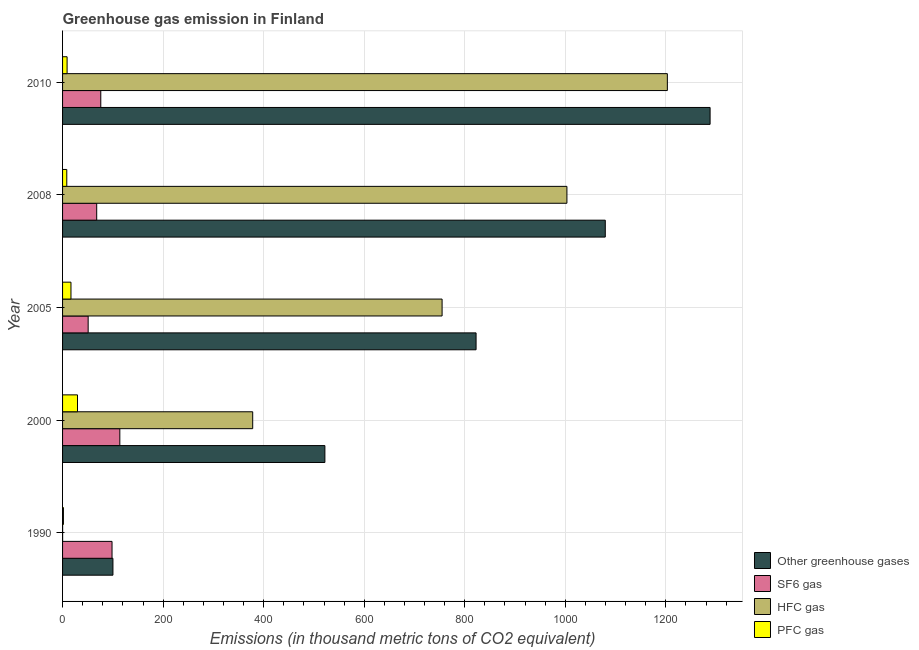How many groups of bars are there?
Keep it short and to the point. 5. Are the number of bars on each tick of the Y-axis equal?
Your answer should be very brief. Yes. In how many cases, is the number of bars for a given year not equal to the number of legend labels?
Ensure brevity in your answer.  0. Across all years, what is the maximum emission of sf6 gas?
Your answer should be very brief. 113.9. Across all years, what is the minimum emission of hfc gas?
Ensure brevity in your answer.  0.1. In which year was the emission of pfc gas minimum?
Your response must be concise. 1990. What is the total emission of sf6 gas in the graph?
Keep it short and to the point. 407.1. What is the difference between the emission of greenhouse gases in 2005 and that in 2010?
Keep it short and to the point. -465.5. What is the difference between the emission of hfc gas in 2008 and the emission of greenhouse gases in 2005?
Provide a succinct answer. 180.7. What is the average emission of greenhouse gases per year?
Ensure brevity in your answer.  762.4. In how many years, is the emission of hfc gas greater than 1280 thousand metric tons?
Make the answer very short. 0. What is the ratio of the emission of greenhouse gases in 2005 to that in 2008?
Your answer should be compact. 0.76. What is the difference between the highest and the second highest emission of pfc gas?
Keep it short and to the point. 13. What is the difference between the highest and the lowest emission of hfc gas?
Offer a terse response. 1202.9. In how many years, is the emission of hfc gas greater than the average emission of hfc gas taken over all years?
Provide a succinct answer. 3. Is it the case that in every year, the sum of the emission of greenhouse gases and emission of sf6 gas is greater than the sum of emission of pfc gas and emission of hfc gas?
Ensure brevity in your answer.  No. What does the 2nd bar from the top in 2000 represents?
Keep it short and to the point. HFC gas. What does the 1st bar from the bottom in 2010 represents?
Ensure brevity in your answer.  Other greenhouse gases. Is it the case that in every year, the sum of the emission of greenhouse gases and emission of sf6 gas is greater than the emission of hfc gas?
Your answer should be very brief. Yes. How many bars are there?
Your answer should be very brief. 20. Where does the legend appear in the graph?
Your answer should be compact. Bottom right. How many legend labels are there?
Offer a terse response. 4. What is the title of the graph?
Provide a short and direct response. Greenhouse gas emission in Finland. Does "PFC gas" appear as one of the legend labels in the graph?
Your answer should be very brief. Yes. What is the label or title of the X-axis?
Your answer should be compact. Emissions (in thousand metric tons of CO2 equivalent). What is the label or title of the Y-axis?
Provide a short and direct response. Year. What is the Emissions (in thousand metric tons of CO2 equivalent) of Other greenhouse gases in 1990?
Offer a terse response. 100.2. What is the Emissions (in thousand metric tons of CO2 equivalent) of SF6 gas in 1990?
Offer a terse response. 98.4. What is the Emissions (in thousand metric tons of CO2 equivalent) of HFC gas in 1990?
Offer a terse response. 0.1. What is the Emissions (in thousand metric tons of CO2 equivalent) of Other greenhouse gases in 2000?
Keep it short and to the point. 521.8. What is the Emissions (in thousand metric tons of CO2 equivalent) of SF6 gas in 2000?
Your answer should be very brief. 113.9. What is the Emissions (in thousand metric tons of CO2 equivalent) in HFC gas in 2000?
Your response must be concise. 378.2. What is the Emissions (in thousand metric tons of CO2 equivalent) of PFC gas in 2000?
Offer a terse response. 29.7. What is the Emissions (in thousand metric tons of CO2 equivalent) of Other greenhouse gases in 2005?
Offer a terse response. 822.5. What is the Emissions (in thousand metric tons of CO2 equivalent) in SF6 gas in 2005?
Offer a terse response. 50.9. What is the Emissions (in thousand metric tons of CO2 equivalent) of HFC gas in 2005?
Provide a succinct answer. 754.9. What is the Emissions (in thousand metric tons of CO2 equivalent) in Other greenhouse gases in 2008?
Provide a succinct answer. 1079.5. What is the Emissions (in thousand metric tons of CO2 equivalent) in SF6 gas in 2008?
Ensure brevity in your answer.  67.9. What is the Emissions (in thousand metric tons of CO2 equivalent) in HFC gas in 2008?
Your answer should be very brief. 1003.2. What is the Emissions (in thousand metric tons of CO2 equivalent) in PFC gas in 2008?
Provide a succinct answer. 8.4. What is the Emissions (in thousand metric tons of CO2 equivalent) in Other greenhouse gases in 2010?
Give a very brief answer. 1288. What is the Emissions (in thousand metric tons of CO2 equivalent) of HFC gas in 2010?
Offer a terse response. 1203. What is the Emissions (in thousand metric tons of CO2 equivalent) in PFC gas in 2010?
Give a very brief answer. 9. Across all years, what is the maximum Emissions (in thousand metric tons of CO2 equivalent) of Other greenhouse gases?
Ensure brevity in your answer.  1288. Across all years, what is the maximum Emissions (in thousand metric tons of CO2 equivalent) of SF6 gas?
Your response must be concise. 113.9. Across all years, what is the maximum Emissions (in thousand metric tons of CO2 equivalent) in HFC gas?
Your response must be concise. 1203. Across all years, what is the maximum Emissions (in thousand metric tons of CO2 equivalent) in PFC gas?
Make the answer very short. 29.7. Across all years, what is the minimum Emissions (in thousand metric tons of CO2 equivalent) of Other greenhouse gases?
Keep it short and to the point. 100.2. Across all years, what is the minimum Emissions (in thousand metric tons of CO2 equivalent) in SF6 gas?
Your response must be concise. 50.9. Across all years, what is the minimum Emissions (in thousand metric tons of CO2 equivalent) in PFC gas?
Your response must be concise. 1.7. What is the total Emissions (in thousand metric tons of CO2 equivalent) in Other greenhouse gases in the graph?
Offer a very short reply. 3812. What is the total Emissions (in thousand metric tons of CO2 equivalent) of SF6 gas in the graph?
Ensure brevity in your answer.  407.1. What is the total Emissions (in thousand metric tons of CO2 equivalent) of HFC gas in the graph?
Offer a very short reply. 3339.4. What is the total Emissions (in thousand metric tons of CO2 equivalent) in PFC gas in the graph?
Provide a short and direct response. 65.5. What is the difference between the Emissions (in thousand metric tons of CO2 equivalent) in Other greenhouse gases in 1990 and that in 2000?
Ensure brevity in your answer.  -421.6. What is the difference between the Emissions (in thousand metric tons of CO2 equivalent) of SF6 gas in 1990 and that in 2000?
Offer a very short reply. -15.5. What is the difference between the Emissions (in thousand metric tons of CO2 equivalent) in HFC gas in 1990 and that in 2000?
Offer a terse response. -378.1. What is the difference between the Emissions (in thousand metric tons of CO2 equivalent) of Other greenhouse gases in 1990 and that in 2005?
Provide a short and direct response. -722.3. What is the difference between the Emissions (in thousand metric tons of CO2 equivalent) of SF6 gas in 1990 and that in 2005?
Your answer should be compact. 47.5. What is the difference between the Emissions (in thousand metric tons of CO2 equivalent) of HFC gas in 1990 and that in 2005?
Your answer should be compact. -754.8. What is the difference between the Emissions (in thousand metric tons of CO2 equivalent) of PFC gas in 1990 and that in 2005?
Offer a terse response. -15. What is the difference between the Emissions (in thousand metric tons of CO2 equivalent) in Other greenhouse gases in 1990 and that in 2008?
Your response must be concise. -979.3. What is the difference between the Emissions (in thousand metric tons of CO2 equivalent) of SF6 gas in 1990 and that in 2008?
Make the answer very short. 30.5. What is the difference between the Emissions (in thousand metric tons of CO2 equivalent) of HFC gas in 1990 and that in 2008?
Provide a succinct answer. -1003.1. What is the difference between the Emissions (in thousand metric tons of CO2 equivalent) in PFC gas in 1990 and that in 2008?
Your response must be concise. -6.7. What is the difference between the Emissions (in thousand metric tons of CO2 equivalent) in Other greenhouse gases in 1990 and that in 2010?
Provide a succinct answer. -1187.8. What is the difference between the Emissions (in thousand metric tons of CO2 equivalent) of SF6 gas in 1990 and that in 2010?
Provide a succinct answer. 22.4. What is the difference between the Emissions (in thousand metric tons of CO2 equivalent) in HFC gas in 1990 and that in 2010?
Your response must be concise. -1202.9. What is the difference between the Emissions (in thousand metric tons of CO2 equivalent) in PFC gas in 1990 and that in 2010?
Keep it short and to the point. -7.3. What is the difference between the Emissions (in thousand metric tons of CO2 equivalent) in Other greenhouse gases in 2000 and that in 2005?
Your answer should be very brief. -300.7. What is the difference between the Emissions (in thousand metric tons of CO2 equivalent) of SF6 gas in 2000 and that in 2005?
Your response must be concise. 63. What is the difference between the Emissions (in thousand metric tons of CO2 equivalent) in HFC gas in 2000 and that in 2005?
Give a very brief answer. -376.7. What is the difference between the Emissions (in thousand metric tons of CO2 equivalent) of PFC gas in 2000 and that in 2005?
Your answer should be very brief. 13. What is the difference between the Emissions (in thousand metric tons of CO2 equivalent) in Other greenhouse gases in 2000 and that in 2008?
Give a very brief answer. -557.7. What is the difference between the Emissions (in thousand metric tons of CO2 equivalent) of HFC gas in 2000 and that in 2008?
Give a very brief answer. -625. What is the difference between the Emissions (in thousand metric tons of CO2 equivalent) in PFC gas in 2000 and that in 2008?
Your response must be concise. 21.3. What is the difference between the Emissions (in thousand metric tons of CO2 equivalent) of Other greenhouse gases in 2000 and that in 2010?
Give a very brief answer. -766.2. What is the difference between the Emissions (in thousand metric tons of CO2 equivalent) of SF6 gas in 2000 and that in 2010?
Keep it short and to the point. 37.9. What is the difference between the Emissions (in thousand metric tons of CO2 equivalent) of HFC gas in 2000 and that in 2010?
Your answer should be compact. -824.8. What is the difference between the Emissions (in thousand metric tons of CO2 equivalent) of PFC gas in 2000 and that in 2010?
Your answer should be very brief. 20.7. What is the difference between the Emissions (in thousand metric tons of CO2 equivalent) in Other greenhouse gases in 2005 and that in 2008?
Provide a short and direct response. -257. What is the difference between the Emissions (in thousand metric tons of CO2 equivalent) of HFC gas in 2005 and that in 2008?
Offer a terse response. -248.3. What is the difference between the Emissions (in thousand metric tons of CO2 equivalent) of PFC gas in 2005 and that in 2008?
Your response must be concise. 8.3. What is the difference between the Emissions (in thousand metric tons of CO2 equivalent) of Other greenhouse gases in 2005 and that in 2010?
Your answer should be very brief. -465.5. What is the difference between the Emissions (in thousand metric tons of CO2 equivalent) in SF6 gas in 2005 and that in 2010?
Your response must be concise. -25.1. What is the difference between the Emissions (in thousand metric tons of CO2 equivalent) in HFC gas in 2005 and that in 2010?
Give a very brief answer. -448.1. What is the difference between the Emissions (in thousand metric tons of CO2 equivalent) of Other greenhouse gases in 2008 and that in 2010?
Ensure brevity in your answer.  -208.5. What is the difference between the Emissions (in thousand metric tons of CO2 equivalent) in SF6 gas in 2008 and that in 2010?
Offer a terse response. -8.1. What is the difference between the Emissions (in thousand metric tons of CO2 equivalent) of HFC gas in 2008 and that in 2010?
Ensure brevity in your answer.  -199.8. What is the difference between the Emissions (in thousand metric tons of CO2 equivalent) of PFC gas in 2008 and that in 2010?
Make the answer very short. -0.6. What is the difference between the Emissions (in thousand metric tons of CO2 equivalent) in Other greenhouse gases in 1990 and the Emissions (in thousand metric tons of CO2 equivalent) in SF6 gas in 2000?
Give a very brief answer. -13.7. What is the difference between the Emissions (in thousand metric tons of CO2 equivalent) in Other greenhouse gases in 1990 and the Emissions (in thousand metric tons of CO2 equivalent) in HFC gas in 2000?
Provide a succinct answer. -278. What is the difference between the Emissions (in thousand metric tons of CO2 equivalent) of Other greenhouse gases in 1990 and the Emissions (in thousand metric tons of CO2 equivalent) of PFC gas in 2000?
Your response must be concise. 70.5. What is the difference between the Emissions (in thousand metric tons of CO2 equivalent) of SF6 gas in 1990 and the Emissions (in thousand metric tons of CO2 equivalent) of HFC gas in 2000?
Offer a terse response. -279.8. What is the difference between the Emissions (in thousand metric tons of CO2 equivalent) in SF6 gas in 1990 and the Emissions (in thousand metric tons of CO2 equivalent) in PFC gas in 2000?
Keep it short and to the point. 68.7. What is the difference between the Emissions (in thousand metric tons of CO2 equivalent) in HFC gas in 1990 and the Emissions (in thousand metric tons of CO2 equivalent) in PFC gas in 2000?
Provide a succinct answer. -29.6. What is the difference between the Emissions (in thousand metric tons of CO2 equivalent) in Other greenhouse gases in 1990 and the Emissions (in thousand metric tons of CO2 equivalent) in SF6 gas in 2005?
Provide a short and direct response. 49.3. What is the difference between the Emissions (in thousand metric tons of CO2 equivalent) of Other greenhouse gases in 1990 and the Emissions (in thousand metric tons of CO2 equivalent) of HFC gas in 2005?
Your response must be concise. -654.7. What is the difference between the Emissions (in thousand metric tons of CO2 equivalent) of Other greenhouse gases in 1990 and the Emissions (in thousand metric tons of CO2 equivalent) of PFC gas in 2005?
Provide a succinct answer. 83.5. What is the difference between the Emissions (in thousand metric tons of CO2 equivalent) in SF6 gas in 1990 and the Emissions (in thousand metric tons of CO2 equivalent) in HFC gas in 2005?
Ensure brevity in your answer.  -656.5. What is the difference between the Emissions (in thousand metric tons of CO2 equivalent) in SF6 gas in 1990 and the Emissions (in thousand metric tons of CO2 equivalent) in PFC gas in 2005?
Provide a short and direct response. 81.7. What is the difference between the Emissions (in thousand metric tons of CO2 equivalent) of HFC gas in 1990 and the Emissions (in thousand metric tons of CO2 equivalent) of PFC gas in 2005?
Give a very brief answer. -16.6. What is the difference between the Emissions (in thousand metric tons of CO2 equivalent) of Other greenhouse gases in 1990 and the Emissions (in thousand metric tons of CO2 equivalent) of SF6 gas in 2008?
Offer a very short reply. 32.3. What is the difference between the Emissions (in thousand metric tons of CO2 equivalent) of Other greenhouse gases in 1990 and the Emissions (in thousand metric tons of CO2 equivalent) of HFC gas in 2008?
Make the answer very short. -903. What is the difference between the Emissions (in thousand metric tons of CO2 equivalent) of Other greenhouse gases in 1990 and the Emissions (in thousand metric tons of CO2 equivalent) of PFC gas in 2008?
Your answer should be compact. 91.8. What is the difference between the Emissions (in thousand metric tons of CO2 equivalent) of SF6 gas in 1990 and the Emissions (in thousand metric tons of CO2 equivalent) of HFC gas in 2008?
Your answer should be compact. -904.8. What is the difference between the Emissions (in thousand metric tons of CO2 equivalent) in SF6 gas in 1990 and the Emissions (in thousand metric tons of CO2 equivalent) in PFC gas in 2008?
Keep it short and to the point. 90. What is the difference between the Emissions (in thousand metric tons of CO2 equivalent) in Other greenhouse gases in 1990 and the Emissions (in thousand metric tons of CO2 equivalent) in SF6 gas in 2010?
Your answer should be very brief. 24.2. What is the difference between the Emissions (in thousand metric tons of CO2 equivalent) in Other greenhouse gases in 1990 and the Emissions (in thousand metric tons of CO2 equivalent) in HFC gas in 2010?
Give a very brief answer. -1102.8. What is the difference between the Emissions (in thousand metric tons of CO2 equivalent) in Other greenhouse gases in 1990 and the Emissions (in thousand metric tons of CO2 equivalent) in PFC gas in 2010?
Offer a very short reply. 91.2. What is the difference between the Emissions (in thousand metric tons of CO2 equivalent) in SF6 gas in 1990 and the Emissions (in thousand metric tons of CO2 equivalent) in HFC gas in 2010?
Provide a short and direct response. -1104.6. What is the difference between the Emissions (in thousand metric tons of CO2 equivalent) of SF6 gas in 1990 and the Emissions (in thousand metric tons of CO2 equivalent) of PFC gas in 2010?
Your response must be concise. 89.4. What is the difference between the Emissions (in thousand metric tons of CO2 equivalent) in HFC gas in 1990 and the Emissions (in thousand metric tons of CO2 equivalent) in PFC gas in 2010?
Your response must be concise. -8.9. What is the difference between the Emissions (in thousand metric tons of CO2 equivalent) of Other greenhouse gases in 2000 and the Emissions (in thousand metric tons of CO2 equivalent) of SF6 gas in 2005?
Make the answer very short. 470.9. What is the difference between the Emissions (in thousand metric tons of CO2 equivalent) in Other greenhouse gases in 2000 and the Emissions (in thousand metric tons of CO2 equivalent) in HFC gas in 2005?
Provide a succinct answer. -233.1. What is the difference between the Emissions (in thousand metric tons of CO2 equivalent) in Other greenhouse gases in 2000 and the Emissions (in thousand metric tons of CO2 equivalent) in PFC gas in 2005?
Keep it short and to the point. 505.1. What is the difference between the Emissions (in thousand metric tons of CO2 equivalent) in SF6 gas in 2000 and the Emissions (in thousand metric tons of CO2 equivalent) in HFC gas in 2005?
Offer a very short reply. -641. What is the difference between the Emissions (in thousand metric tons of CO2 equivalent) of SF6 gas in 2000 and the Emissions (in thousand metric tons of CO2 equivalent) of PFC gas in 2005?
Your response must be concise. 97.2. What is the difference between the Emissions (in thousand metric tons of CO2 equivalent) in HFC gas in 2000 and the Emissions (in thousand metric tons of CO2 equivalent) in PFC gas in 2005?
Your answer should be compact. 361.5. What is the difference between the Emissions (in thousand metric tons of CO2 equivalent) in Other greenhouse gases in 2000 and the Emissions (in thousand metric tons of CO2 equivalent) in SF6 gas in 2008?
Offer a terse response. 453.9. What is the difference between the Emissions (in thousand metric tons of CO2 equivalent) in Other greenhouse gases in 2000 and the Emissions (in thousand metric tons of CO2 equivalent) in HFC gas in 2008?
Your response must be concise. -481.4. What is the difference between the Emissions (in thousand metric tons of CO2 equivalent) of Other greenhouse gases in 2000 and the Emissions (in thousand metric tons of CO2 equivalent) of PFC gas in 2008?
Your response must be concise. 513.4. What is the difference between the Emissions (in thousand metric tons of CO2 equivalent) in SF6 gas in 2000 and the Emissions (in thousand metric tons of CO2 equivalent) in HFC gas in 2008?
Make the answer very short. -889.3. What is the difference between the Emissions (in thousand metric tons of CO2 equivalent) of SF6 gas in 2000 and the Emissions (in thousand metric tons of CO2 equivalent) of PFC gas in 2008?
Give a very brief answer. 105.5. What is the difference between the Emissions (in thousand metric tons of CO2 equivalent) of HFC gas in 2000 and the Emissions (in thousand metric tons of CO2 equivalent) of PFC gas in 2008?
Offer a very short reply. 369.8. What is the difference between the Emissions (in thousand metric tons of CO2 equivalent) in Other greenhouse gases in 2000 and the Emissions (in thousand metric tons of CO2 equivalent) in SF6 gas in 2010?
Provide a short and direct response. 445.8. What is the difference between the Emissions (in thousand metric tons of CO2 equivalent) in Other greenhouse gases in 2000 and the Emissions (in thousand metric tons of CO2 equivalent) in HFC gas in 2010?
Your response must be concise. -681.2. What is the difference between the Emissions (in thousand metric tons of CO2 equivalent) of Other greenhouse gases in 2000 and the Emissions (in thousand metric tons of CO2 equivalent) of PFC gas in 2010?
Ensure brevity in your answer.  512.8. What is the difference between the Emissions (in thousand metric tons of CO2 equivalent) in SF6 gas in 2000 and the Emissions (in thousand metric tons of CO2 equivalent) in HFC gas in 2010?
Give a very brief answer. -1089.1. What is the difference between the Emissions (in thousand metric tons of CO2 equivalent) of SF6 gas in 2000 and the Emissions (in thousand metric tons of CO2 equivalent) of PFC gas in 2010?
Offer a very short reply. 104.9. What is the difference between the Emissions (in thousand metric tons of CO2 equivalent) of HFC gas in 2000 and the Emissions (in thousand metric tons of CO2 equivalent) of PFC gas in 2010?
Your answer should be compact. 369.2. What is the difference between the Emissions (in thousand metric tons of CO2 equivalent) in Other greenhouse gases in 2005 and the Emissions (in thousand metric tons of CO2 equivalent) in SF6 gas in 2008?
Your response must be concise. 754.6. What is the difference between the Emissions (in thousand metric tons of CO2 equivalent) of Other greenhouse gases in 2005 and the Emissions (in thousand metric tons of CO2 equivalent) of HFC gas in 2008?
Your answer should be very brief. -180.7. What is the difference between the Emissions (in thousand metric tons of CO2 equivalent) in Other greenhouse gases in 2005 and the Emissions (in thousand metric tons of CO2 equivalent) in PFC gas in 2008?
Your answer should be compact. 814.1. What is the difference between the Emissions (in thousand metric tons of CO2 equivalent) of SF6 gas in 2005 and the Emissions (in thousand metric tons of CO2 equivalent) of HFC gas in 2008?
Your answer should be very brief. -952.3. What is the difference between the Emissions (in thousand metric tons of CO2 equivalent) in SF6 gas in 2005 and the Emissions (in thousand metric tons of CO2 equivalent) in PFC gas in 2008?
Offer a very short reply. 42.5. What is the difference between the Emissions (in thousand metric tons of CO2 equivalent) in HFC gas in 2005 and the Emissions (in thousand metric tons of CO2 equivalent) in PFC gas in 2008?
Your answer should be very brief. 746.5. What is the difference between the Emissions (in thousand metric tons of CO2 equivalent) in Other greenhouse gases in 2005 and the Emissions (in thousand metric tons of CO2 equivalent) in SF6 gas in 2010?
Keep it short and to the point. 746.5. What is the difference between the Emissions (in thousand metric tons of CO2 equivalent) of Other greenhouse gases in 2005 and the Emissions (in thousand metric tons of CO2 equivalent) of HFC gas in 2010?
Ensure brevity in your answer.  -380.5. What is the difference between the Emissions (in thousand metric tons of CO2 equivalent) in Other greenhouse gases in 2005 and the Emissions (in thousand metric tons of CO2 equivalent) in PFC gas in 2010?
Your answer should be very brief. 813.5. What is the difference between the Emissions (in thousand metric tons of CO2 equivalent) of SF6 gas in 2005 and the Emissions (in thousand metric tons of CO2 equivalent) of HFC gas in 2010?
Keep it short and to the point. -1152.1. What is the difference between the Emissions (in thousand metric tons of CO2 equivalent) of SF6 gas in 2005 and the Emissions (in thousand metric tons of CO2 equivalent) of PFC gas in 2010?
Give a very brief answer. 41.9. What is the difference between the Emissions (in thousand metric tons of CO2 equivalent) of HFC gas in 2005 and the Emissions (in thousand metric tons of CO2 equivalent) of PFC gas in 2010?
Provide a succinct answer. 745.9. What is the difference between the Emissions (in thousand metric tons of CO2 equivalent) in Other greenhouse gases in 2008 and the Emissions (in thousand metric tons of CO2 equivalent) in SF6 gas in 2010?
Your answer should be very brief. 1003.5. What is the difference between the Emissions (in thousand metric tons of CO2 equivalent) in Other greenhouse gases in 2008 and the Emissions (in thousand metric tons of CO2 equivalent) in HFC gas in 2010?
Offer a very short reply. -123.5. What is the difference between the Emissions (in thousand metric tons of CO2 equivalent) in Other greenhouse gases in 2008 and the Emissions (in thousand metric tons of CO2 equivalent) in PFC gas in 2010?
Your response must be concise. 1070.5. What is the difference between the Emissions (in thousand metric tons of CO2 equivalent) in SF6 gas in 2008 and the Emissions (in thousand metric tons of CO2 equivalent) in HFC gas in 2010?
Give a very brief answer. -1135.1. What is the difference between the Emissions (in thousand metric tons of CO2 equivalent) of SF6 gas in 2008 and the Emissions (in thousand metric tons of CO2 equivalent) of PFC gas in 2010?
Offer a very short reply. 58.9. What is the difference between the Emissions (in thousand metric tons of CO2 equivalent) in HFC gas in 2008 and the Emissions (in thousand metric tons of CO2 equivalent) in PFC gas in 2010?
Your response must be concise. 994.2. What is the average Emissions (in thousand metric tons of CO2 equivalent) of Other greenhouse gases per year?
Your answer should be compact. 762.4. What is the average Emissions (in thousand metric tons of CO2 equivalent) in SF6 gas per year?
Your answer should be very brief. 81.42. What is the average Emissions (in thousand metric tons of CO2 equivalent) of HFC gas per year?
Provide a succinct answer. 667.88. In the year 1990, what is the difference between the Emissions (in thousand metric tons of CO2 equivalent) of Other greenhouse gases and Emissions (in thousand metric tons of CO2 equivalent) of SF6 gas?
Give a very brief answer. 1.8. In the year 1990, what is the difference between the Emissions (in thousand metric tons of CO2 equivalent) in Other greenhouse gases and Emissions (in thousand metric tons of CO2 equivalent) in HFC gas?
Your answer should be very brief. 100.1. In the year 1990, what is the difference between the Emissions (in thousand metric tons of CO2 equivalent) of Other greenhouse gases and Emissions (in thousand metric tons of CO2 equivalent) of PFC gas?
Provide a short and direct response. 98.5. In the year 1990, what is the difference between the Emissions (in thousand metric tons of CO2 equivalent) of SF6 gas and Emissions (in thousand metric tons of CO2 equivalent) of HFC gas?
Provide a succinct answer. 98.3. In the year 1990, what is the difference between the Emissions (in thousand metric tons of CO2 equivalent) of SF6 gas and Emissions (in thousand metric tons of CO2 equivalent) of PFC gas?
Give a very brief answer. 96.7. In the year 2000, what is the difference between the Emissions (in thousand metric tons of CO2 equivalent) of Other greenhouse gases and Emissions (in thousand metric tons of CO2 equivalent) of SF6 gas?
Keep it short and to the point. 407.9. In the year 2000, what is the difference between the Emissions (in thousand metric tons of CO2 equivalent) in Other greenhouse gases and Emissions (in thousand metric tons of CO2 equivalent) in HFC gas?
Make the answer very short. 143.6. In the year 2000, what is the difference between the Emissions (in thousand metric tons of CO2 equivalent) in Other greenhouse gases and Emissions (in thousand metric tons of CO2 equivalent) in PFC gas?
Your response must be concise. 492.1. In the year 2000, what is the difference between the Emissions (in thousand metric tons of CO2 equivalent) of SF6 gas and Emissions (in thousand metric tons of CO2 equivalent) of HFC gas?
Your answer should be compact. -264.3. In the year 2000, what is the difference between the Emissions (in thousand metric tons of CO2 equivalent) of SF6 gas and Emissions (in thousand metric tons of CO2 equivalent) of PFC gas?
Provide a succinct answer. 84.2. In the year 2000, what is the difference between the Emissions (in thousand metric tons of CO2 equivalent) in HFC gas and Emissions (in thousand metric tons of CO2 equivalent) in PFC gas?
Keep it short and to the point. 348.5. In the year 2005, what is the difference between the Emissions (in thousand metric tons of CO2 equivalent) of Other greenhouse gases and Emissions (in thousand metric tons of CO2 equivalent) of SF6 gas?
Ensure brevity in your answer.  771.6. In the year 2005, what is the difference between the Emissions (in thousand metric tons of CO2 equivalent) of Other greenhouse gases and Emissions (in thousand metric tons of CO2 equivalent) of HFC gas?
Your response must be concise. 67.6. In the year 2005, what is the difference between the Emissions (in thousand metric tons of CO2 equivalent) of Other greenhouse gases and Emissions (in thousand metric tons of CO2 equivalent) of PFC gas?
Give a very brief answer. 805.8. In the year 2005, what is the difference between the Emissions (in thousand metric tons of CO2 equivalent) in SF6 gas and Emissions (in thousand metric tons of CO2 equivalent) in HFC gas?
Your response must be concise. -704. In the year 2005, what is the difference between the Emissions (in thousand metric tons of CO2 equivalent) in SF6 gas and Emissions (in thousand metric tons of CO2 equivalent) in PFC gas?
Offer a very short reply. 34.2. In the year 2005, what is the difference between the Emissions (in thousand metric tons of CO2 equivalent) in HFC gas and Emissions (in thousand metric tons of CO2 equivalent) in PFC gas?
Make the answer very short. 738.2. In the year 2008, what is the difference between the Emissions (in thousand metric tons of CO2 equivalent) of Other greenhouse gases and Emissions (in thousand metric tons of CO2 equivalent) of SF6 gas?
Provide a short and direct response. 1011.6. In the year 2008, what is the difference between the Emissions (in thousand metric tons of CO2 equivalent) in Other greenhouse gases and Emissions (in thousand metric tons of CO2 equivalent) in HFC gas?
Provide a succinct answer. 76.3. In the year 2008, what is the difference between the Emissions (in thousand metric tons of CO2 equivalent) in Other greenhouse gases and Emissions (in thousand metric tons of CO2 equivalent) in PFC gas?
Your response must be concise. 1071.1. In the year 2008, what is the difference between the Emissions (in thousand metric tons of CO2 equivalent) of SF6 gas and Emissions (in thousand metric tons of CO2 equivalent) of HFC gas?
Make the answer very short. -935.3. In the year 2008, what is the difference between the Emissions (in thousand metric tons of CO2 equivalent) of SF6 gas and Emissions (in thousand metric tons of CO2 equivalent) of PFC gas?
Your response must be concise. 59.5. In the year 2008, what is the difference between the Emissions (in thousand metric tons of CO2 equivalent) in HFC gas and Emissions (in thousand metric tons of CO2 equivalent) in PFC gas?
Make the answer very short. 994.8. In the year 2010, what is the difference between the Emissions (in thousand metric tons of CO2 equivalent) of Other greenhouse gases and Emissions (in thousand metric tons of CO2 equivalent) of SF6 gas?
Your answer should be very brief. 1212. In the year 2010, what is the difference between the Emissions (in thousand metric tons of CO2 equivalent) in Other greenhouse gases and Emissions (in thousand metric tons of CO2 equivalent) in PFC gas?
Provide a succinct answer. 1279. In the year 2010, what is the difference between the Emissions (in thousand metric tons of CO2 equivalent) in SF6 gas and Emissions (in thousand metric tons of CO2 equivalent) in HFC gas?
Your answer should be very brief. -1127. In the year 2010, what is the difference between the Emissions (in thousand metric tons of CO2 equivalent) of HFC gas and Emissions (in thousand metric tons of CO2 equivalent) of PFC gas?
Provide a succinct answer. 1194. What is the ratio of the Emissions (in thousand metric tons of CO2 equivalent) of Other greenhouse gases in 1990 to that in 2000?
Ensure brevity in your answer.  0.19. What is the ratio of the Emissions (in thousand metric tons of CO2 equivalent) of SF6 gas in 1990 to that in 2000?
Ensure brevity in your answer.  0.86. What is the ratio of the Emissions (in thousand metric tons of CO2 equivalent) in PFC gas in 1990 to that in 2000?
Provide a short and direct response. 0.06. What is the ratio of the Emissions (in thousand metric tons of CO2 equivalent) in Other greenhouse gases in 1990 to that in 2005?
Ensure brevity in your answer.  0.12. What is the ratio of the Emissions (in thousand metric tons of CO2 equivalent) of SF6 gas in 1990 to that in 2005?
Keep it short and to the point. 1.93. What is the ratio of the Emissions (in thousand metric tons of CO2 equivalent) in PFC gas in 1990 to that in 2005?
Give a very brief answer. 0.1. What is the ratio of the Emissions (in thousand metric tons of CO2 equivalent) of Other greenhouse gases in 1990 to that in 2008?
Offer a terse response. 0.09. What is the ratio of the Emissions (in thousand metric tons of CO2 equivalent) in SF6 gas in 1990 to that in 2008?
Provide a short and direct response. 1.45. What is the ratio of the Emissions (in thousand metric tons of CO2 equivalent) of PFC gas in 1990 to that in 2008?
Provide a short and direct response. 0.2. What is the ratio of the Emissions (in thousand metric tons of CO2 equivalent) of Other greenhouse gases in 1990 to that in 2010?
Your answer should be compact. 0.08. What is the ratio of the Emissions (in thousand metric tons of CO2 equivalent) of SF6 gas in 1990 to that in 2010?
Offer a very short reply. 1.29. What is the ratio of the Emissions (in thousand metric tons of CO2 equivalent) in HFC gas in 1990 to that in 2010?
Your response must be concise. 0. What is the ratio of the Emissions (in thousand metric tons of CO2 equivalent) of PFC gas in 1990 to that in 2010?
Offer a very short reply. 0.19. What is the ratio of the Emissions (in thousand metric tons of CO2 equivalent) of Other greenhouse gases in 2000 to that in 2005?
Ensure brevity in your answer.  0.63. What is the ratio of the Emissions (in thousand metric tons of CO2 equivalent) in SF6 gas in 2000 to that in 2005?
Your answer should be very brief. 2.24. What is the ratio of the Emissions (in thousand metric tons of CO2 equivalent) in HFC gas in 2000 to that in 2005?
Keep it short and to the point. 0.5. What is the ratio of the Emissions (in thousand metric tons of CO2 equivalent) in PFC gas in 2000 to that in 2005?
Keep it short and to the point. 1.78. What is the ratio of the Emissions (in thousand metric tons of CO2 equivalent) in Other greenhouse gases in 2000 to that in 2008?
Provide a succinct answer. 0.48. What is the ratio of the Emissions (in thousand metric tons of CO2 equivalent) of SF6 gas in 2000 to that in 2008?
Ensure brevity in your answer.  1.68. What is the ratio of the Emissions (in thousand metric tons of CO2 equivalent) of HFC gas in 2000 to that in 2008?
Ensure brevity in your answer.  0.38. What is the ratio of the Emissions (in thousand metric tons of CO2 equivalent) in PFC gas in 2000 to that in 2008?
Your answer should be very brief. 3.54. What is the ratio of the Emissions (in thousand metric tons of CO2 equivalent) of Other greenhouse gases in 2000 to that in 2010?
Keep it short and to the point. 0.41. What is the ratio of the Emissions (in thousand metric tons of CO2 equivalent) of SF6 gas in 2000 to that in 2010?
Give a very brief answer. 1.5. What is the ratio of the Emissions (in thousand metric tons of CO2 equivalent) of HFC gas in 2000 to that in 2010?
Provide a succinct answer. 0.31. What is the ratio of the Emissions (in thousand metric tons of CO2 equivalent) of Other greenhouse gases in 2005 to that in 2008?
Offer a terse response. 0.76. What is the ratio of the Emissions (in thousand metric tons of CO2 equivalent) in SF6 gas in 2005 to that in 2008?
Provide a succinct answer. 0.75. What is the ratio of the Emissions (in thousand metric tons of CO2 equivalent) in HFC gas in 2005 to that in 2008?
Your answer should be very brief. 0.75. What is the ratio of the Emissions (in thousand metric tons of CO2 equivalent) of PFC gas in 2005 to that in 2008?
Offer a very short reply. 1.99. What is the ratio of the Emissions (in thousand metric tons of CO2 equivalent) in Other greenhouse gases in 2005 to that in 2010?
Provide a short and direct response. 0.64. What is the ratio of the Emissions (in thousand metric tons of CO2 equivalent) of SF6 gas in 2005 to that in 2010?
Ensure brevity in your answer.  0.67. What is the ratio of the Emissions (in thousand metric tons of CO2 equivalent) of HFC gas in 2005 to that in 2010?
Provide a succinct answer. 0.63. What is the ratio of the Emissions (in thousand metric tons of CO2 equivalent) of PFC gas in 2005 to that in 2010?
Provide a short and direct response. 1.86. What is the ratio of the Emissions (in thousand metric tons of CO2 equivalent) in Other greenhouse gases in 2008 to that in 2010?
Your answer should be compact. 0.84. What is the ratio of the Emissions (in thousand metric tons of CO2 equivalent) in SF6 gas in 2008 to that in 2010?
Give a very brief answer. 0.89. What is the ratio of the Emissions (in thousand metric tons of CO2 equivalent) in HFC gas in 2008 to that in 2010?
Provide a short and direct response. 0.83. What is the ratio of the Emissions (in thousand metric tons of CO2 equivalent) of PFC gas in 2008 to that in 2010?
Ensure brevity in your answer.  0.93. What is the difference between the highest and the second highest Emissions (in thousand metric tons of CO2 equivalent) of Other greenhouse gases?
Your response must be concise. 208.5. What is the difference between the highest and the second highest Emissions (in thousand metric tons of CO2 equivalent) of HFC gas?
Your answer should be compact. 199.8. What is the difference between the highest and the second highest Emissions (in thousand metric tons of CO2 equivalent) of PFC gas?
Your answer should be compact. 13. What is the difference between the highest and the lowest Emissions (in thousand metric tons of CO2 equivalent) in Other greenhouse gases?
Provide a short and direct response. 1187.8. What is the difference between the highest and the lowest Emissions (in thousand metric tons of CO2 equivalent) of SF6 gas?
Provide a succinct answer. 63. What is the difference between the highest and the lowest Emissions (in thousand metric tons of CO2 equivalent) in HFC gas?
Your answer should be very brief. 1202.9. What is the difference between the highest and the lowest Emissions (in thousand metric tons of CO2 equivalent) of PFC gas?
Your answer should be compact. 28. 